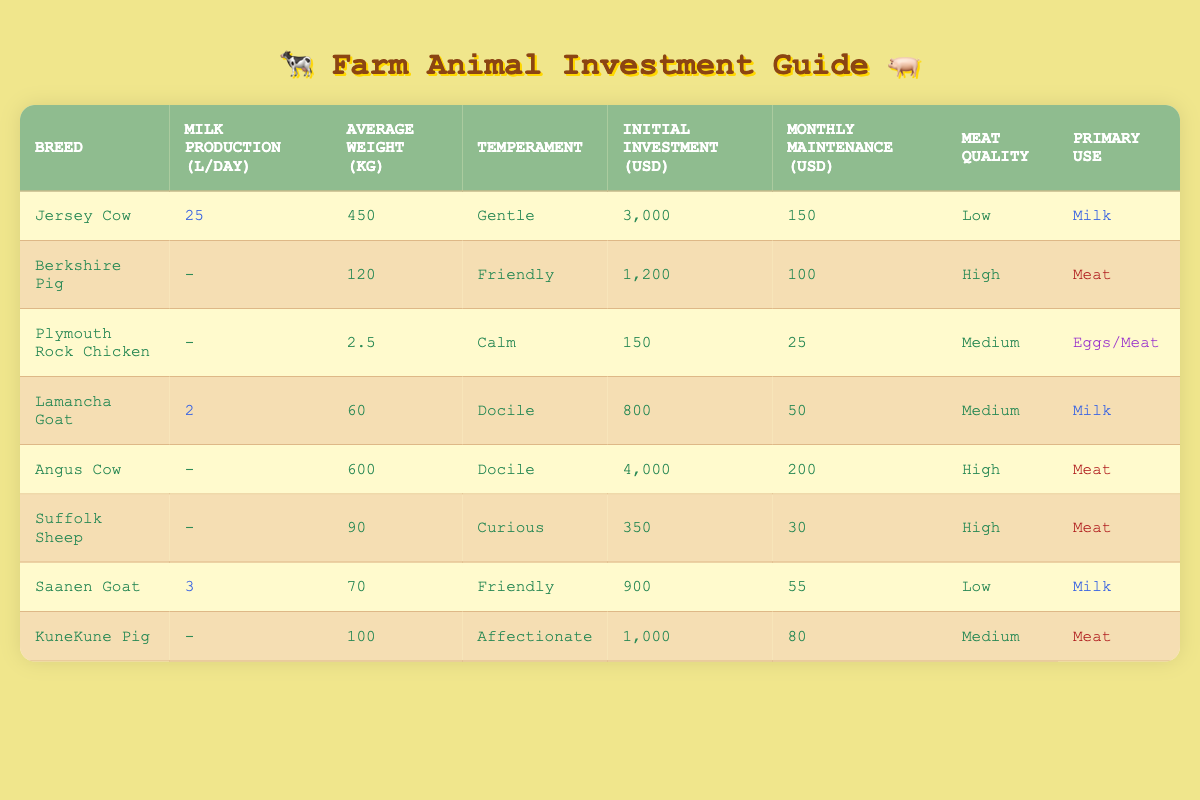What is the milk production per day for a Jersey Cow? The table indicates that the Jersey Cow has a milk production of 25 liters per day, which is clearly stated in the second column corresponding to the Jersey Cow row.
Answer: 25 liters What is the initial investment for an Angus Cow? The table shows that the initial investment for an Angus Cow is 4000 USD, which is placed in the fifth column of the Angus Cow row.
Answer: 4000 USD Which breed has the highest monthly maintenance cost? By examining the table, we see the Angus Cow has the highest monthly maintenance cost at 200 USD, which is the maximum amount found in the corresponding column for maintenance costs.
Answer: Angus Cow Is the temperament of a Berkshire Pig friendly? The table indicates that the temperament of a Berkshire Pig is labeled "Friendly", found in the fourth column corresponding to that breed. Thus, this statement is true.
Answer: Yes How many breeds produce milk? Evaluating the table, we find the breeds that produce milk are Jersey Cow, Lamancha Goat, and Saanen Goat. Counting these shows a total of 3 breeds.
Answer: 3 What is the total initial investment for a Jersey Cow and a Saanen Goat? To calculate this, we add the initial investments for both breeds: Jersey Cow is 3000 USD and Saanen Goat is 900 USD, making the statement 3000 + 900 = 3900 USD total.
Answer: 3900 USD Which breed has a lower maintenance cost, the Plymouth Rock Chicken or the KuneKune Pig? Checking the maintenance costs, Plymouth Rock Chicken has a cost of 25 USD while KuneKune Pig is at 80 USD. Therefore, the maintenance cost for Plymouth Rock Chicken is lower.
Answer: Plymouth Rock Chicken What is the average weight of docile temperament breeds? The docile breeds are Lamancha Goat and Angus Cow, weighing 60 kg and 600 kg, respectively. To find the average, we sum the weights (60 + 600 = 660 kg) and divide by the number of breeds (2), giving us an average weight of 330 kg.
Answer: 330 kg 